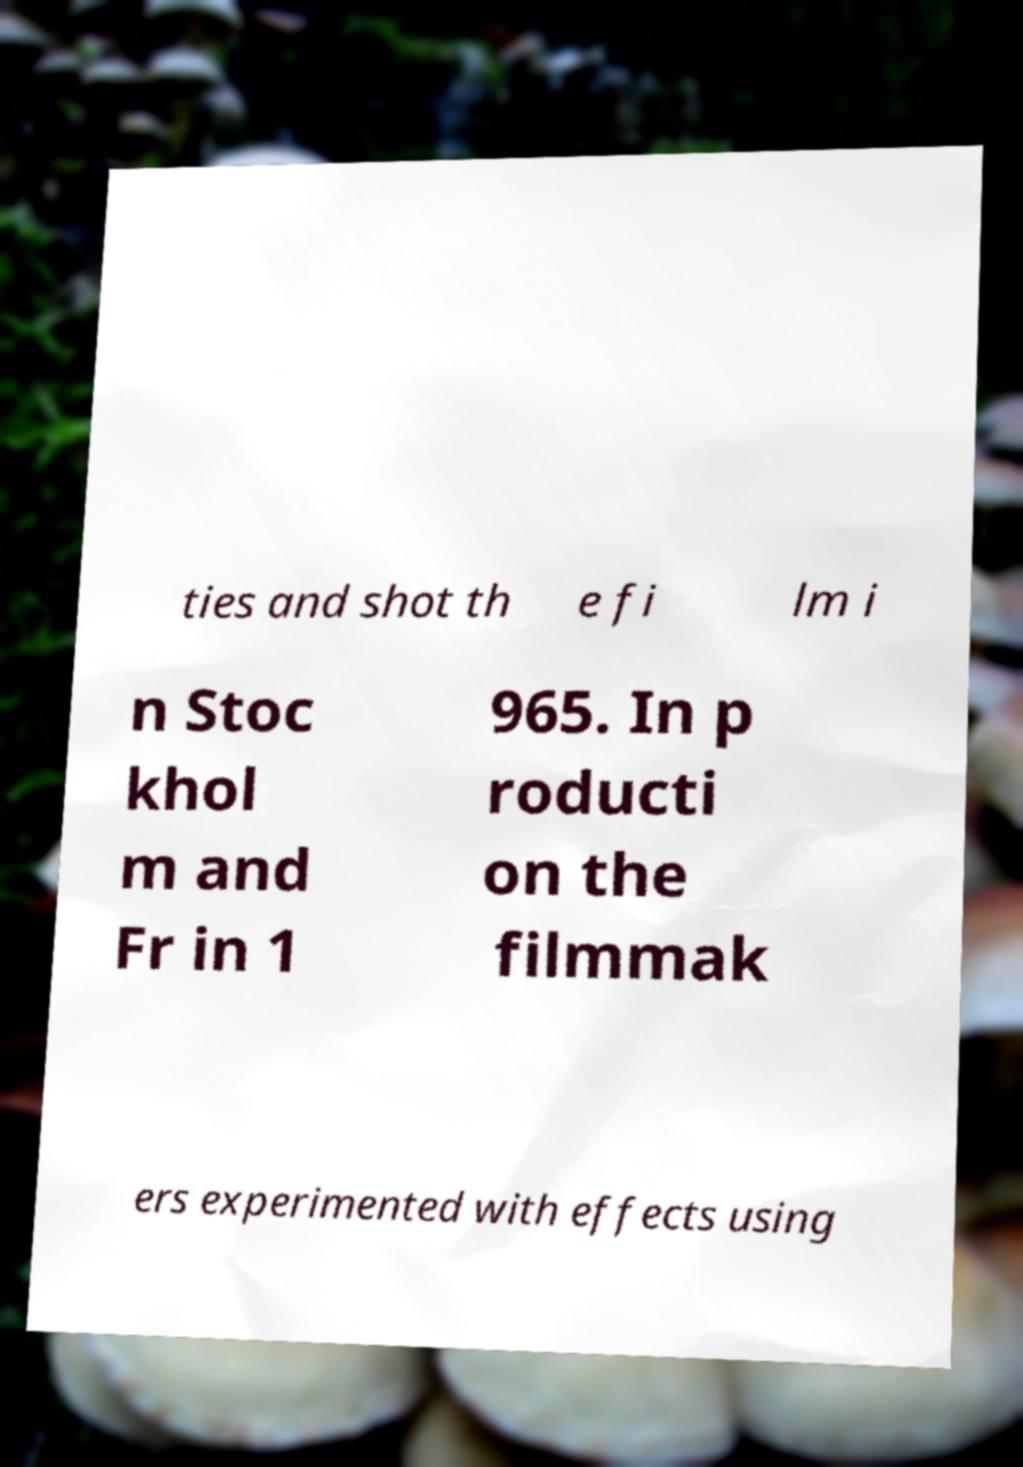Could you extract and type out the text from this image? ties and shot th e fi lm i n Stoc khol m and Fr in 1 965. In p roducti on the filmmak ers experimented with effects using 